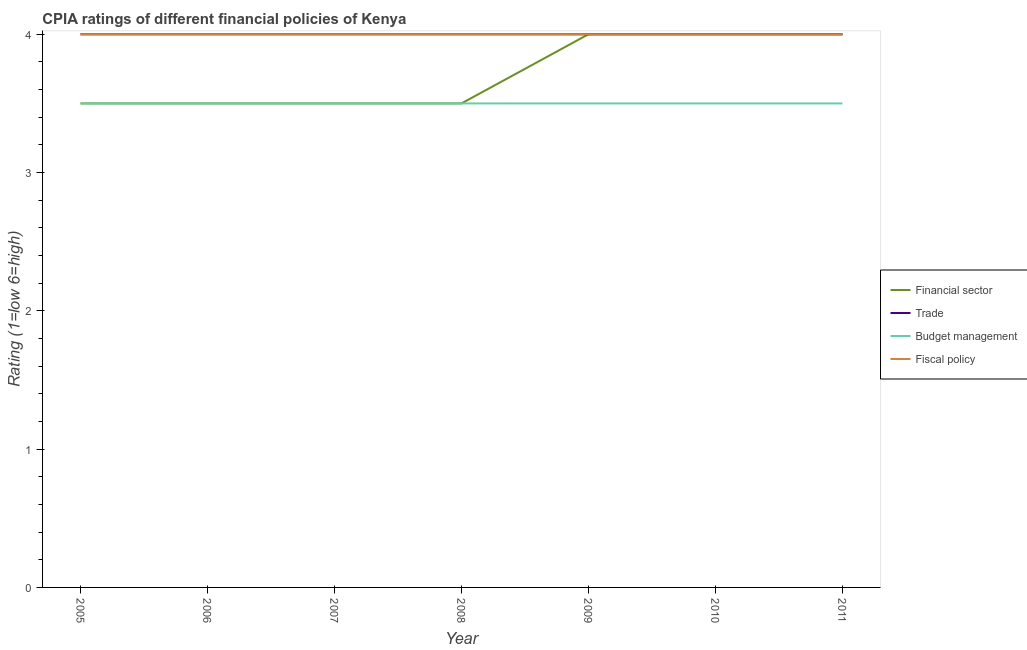Does the line corresponding to cpia rating of budget management intersect with the line corresponding to cpia rating of fiscal policy?
Provide a succinct answer. No. Across all years, what is the maximum cpia rating of budget management?
Your answer should be compact. 3.5. In which year was the cpia rating of fiscal policy minimum?
Keep it short and to the point. 2005. What is the total cpia rating of financial sector in the graph?
Provide a succinct answer. 26. What is the difference between the cpia rating of budget management in 2005 and that in 2008?
Your answer should be very brief. 0. What is the average cpia rating of financial sector per year?
Provide a succinct answer. 3.71. In the year 2011, what is the difference between the cpia rating of financial sector and cpia rating of budget management?
Your answer should be compact. 0.5. What is the ratio of the cpia rating of financial sector in 2008 to that in 2010?
Ensure brevity in your answer.  0.88. Is the cpia rating of fiscal policy in 2008 less than that in 2011?
Offer a very short reply. No. What is the difference between the highest and the second highest cpia rating of budget management?
Provide a short and direct response. 0. Is it the case that in every year, the sum of the cpia rating of fiscal policy and cpia rating of trade is greater than the sum of cpia rating of financial sector and cpia rating of budget management?
Your response must be concise. No. Does the cpia rating of trade monotonically increase over the years?
Offer a very short reply. No. Is the cpia rating of fiscal policy strictly less than the cpia rating of budget management over the years?
Your answer should be very brief. No. What is the difference between two consecutive major ticks on the Y-axis?
Your response must be concise. 1. How are the legend labels stacked?
Keep it short and to the point. Vertical. What is the title of the graph?
Offer a very short reply. CPIA ratings of different financial policies of Kenya. What is the label or title of the X-axis?
Provide a succinct answer. Year. What is the Rating (1=low 6=high) in Fiscal policy in 2005?
Give a very brief answer. 4. What is the Rating (1=low 6=high) of Financial sector in 2006?
Your response must be concise. 3.5. What is the Rating (1=low 6=high) in Budget management in 2006?
Your answer should be very brief. 3.5. What is the Rating (1=low 6=high) in Trade in 2007?
Keep it short and to the point. 4. What is the Rating (1=low 6=high) of Fiscal policy in 2007?
Keep it short and to the point. 4. What is the Rating (1=low 6=high) of Financial sector in 2008?
Give a very brief answer. 3.5. What is the Rating (1=low 6=high) in Trade in 2008?
Ensure brevity in your answer.  4. What is the Rating (1=low 6=high) of Budget management in 2008?
Your response must be concise. 3.5. What is the Rating (1=low 6=high) of Budget management in 2009?
Give a very brief answer. 3.5. What is the Rating (1=low 6=high) of Financial sector in 2010?
Offer a very short reply. 4. What is the Rating (1=low 6=high) in Budget management in 2010?
Offer a terse response. 3.5. What is the Rating (1=low 6=high) in Fiscal policy in 2010?
Offer a very short reply. 4. What is the Rating (1=low 6=high) of Trade in 2011?
Ensure brevity in your answer.  4. Across all years, what is the minimum Rating (1=low 6=high) in Fiscal policy?
Give a very brief answer. 4. What is the total Rating (1=low 6=high) of Budget management in the graph?
Ensure brevity in your answer.  24.5. What is the total Rating (1=low 6=high) in Fiscal policy in the graph?
Provide a succinct answer. 28. What is the difference between the Rating (1=low 6=high) in Financial sector in 2005 and that in 2006?
Provide a succinct answer. 0. What is the difference between the Rating (1=low 6=high) of Trade in 2005 and that in 2006?
Offer a terse response. 0. What is the difference between the Rating (1=low 6=high) in Financial sector in 2005 and that in 2007?
Keep it short and to the point. 0. What is the difference between the Rating (1=low 6=high) of Budget management in 2005 and that in 2007?
Provide a succinct answer. 0. What is the difference between the Rating (1=low 6=high) of Budget management in 2005 and that in 2008?
Make the answer very short. 0. What is the difference between the Rating (1=low 6=high) in Fiscal policy in 2005 and that in 2008?
Ensure brevity in your answer.  0. What is the difference between the Rating (1=low 6=high) of Financial sector in 2005 and that in 2009?
Provide a succinct answer. -0.5. What is the difference between the Rating (1=low 6=high) of Trade in 2005 and that in 2009?
Provide a short and direct response. 0. What is the difference between the Rating (1=low 6=high) in Fiscal policy in 2005 and that in 2009?
Offer a very short reply. 0. What is the difference between the Rating (1=low 6=high) in Financial sector in 2005 and that in 2010?
Your answer should be compact. -0.5. What is the difference between the Rating (1=low 6=high) in Trade in 2005 and that in 2010?
Provide a succinct answer. 0. What is the difference between the Rating (1=low 6=high) of Fiscal policy in 2005 and that in 2010?
Provide a short and direct response. 0. What is the difference between the Rating (1=low 6=high) of Financial sector in 2005 and that in 2011?
Provide a short and direct response. -0.5. What is the difference between the Rating (1=low 6=high) of Financial sector in 2006 and that in 2007?
Your response must be concise. 0. What is the difference between the Rating (1=low 6=high) in Trade in 2006 and that in 2008?
Keep it short and to the point. 0. What is the difference between the Rating (1=low 6=high) in Budget management in 2006 and that in 2008?
Offer a terse response. 0. What is the difference between the Rating (1=low 6=high) of Fiscal policy in 2006 and that in 2008?
Provide a succinct answer. 0. What is the difference between the Rating (1=low 6=high) of Financial sector in 2006 and that in 2009?
Your response must be concise. -0.5. What is the difference between the Rating (1=low 6=high) of Trade in 2006 and that in 2009?
Your answer should be very brief. 0. What is the difference between the Rating (1=low 6=high) of Budget management in 2006 and that in 2009?
Keep it short and to the point. 0. What is the difference between the Rating (1=low 6=high) in Trade in 2006 and that in 2010?
Your answer should be very brief. 0. What is the difference between the Rating (1=low 6=high) in Financial sector in 2006 and that in 2011?
Your answer should be very brief. -0.5. What is the difference between the Rating (1=low 6=high) in Trade in 2006 and that in 2011?
Offer a terse response. 0. What is the difference between the Rating (1=low 6=high) of Budget management in 2006 and that in 2011?
Keep it short and to the point. 0. What is the difference between the Rating (1=low 6=high) of Fiscal policy in 2006 and that in 2011?
Your response must be concise. 0. What is the difference between the Rating (1=low 6=high) of Trade in 2007 and that in 2008?
Your answer should be compact. 0. What is the difference between the Rating (1=low 6=high) of Financial sector in 2007 and that in 2009?
Make the answer very short. -0.5. What is the difference between the Rating (1=low 6=high) of Trade in 2007 and that in 2009?
Your answer should be compact. 0. What is the difference between the Rating (1=low 6=high) of Fiscal policy in 2007 and that in 2009?
Give a very brief answer. 0. What is the difference between the Rating (1=low 6=high) in Trade in 2007 and that in 2010?
Your answer should be very brief. 0. What is the difference between the Rating (1=low 6=high) in Budget management in 2007 and that in 2010?
Make the answer very short. 0. What is the difference between the Rating (1=low 6=high) in Trade in 2007 and that in 2011?
Provide a short and direct response. 0. What is the difference between the Rating (1=low 6=high) in Fiscal policy in 2007 and that in 2011?
Provide a succinct answer. 0. What is the difference between the Rating (1=low 6=high) in Financial sector in 2008 and that in 2009?
Your response must be concise. -0.5. What is the difference between the Rating (1=low 6=high) of Trade in 2008 and that in 2009?
Provide a succinct answer. 0. What is the difference between the Rating (1=low 6=high) of Fiscal policy in 2008 and that in 2009?
Offer a very short reply. 0. What is the difference between the Rating (1=low 6=high) in Financial sector in 2008 and that in 2010?
Provide a short and direct response. -0.5. What is the difference between the Rating (1=low 6=high) in Budget management in 2008 and that in 2010?
Your answer should be compact. 0. What is the difference between the Rating (1=low 6=high) in Fiscal policy in 2008 and that in 2010?
Give a very brief answer. 0. What is the difference between the Rating (1=low 6=high) of Budget management in 2008 and that in 2011?
Offer a terse response. 0. What is the difference between the Rating (1=low 6=high) of Financial sector in 2009 and that in 2010?
Give a very brief answer. 0. What is the difference between the Rating (1=low 6=high) in Trade in 2009 and that in 2010?
Your response must be concise. 0. What is the difference between the Rating (1=low 6=high) in Financial sector in 2009 and that in 2011?
Keep it short and to the point. 0. What is the difference between the Rating (1=low 6=high) in Trade in 2009 and that in 2011?
Provide a short and direct response. 0. What is the difference between the Rating (1=low 6=high) of Fiscal policy in 2010 and that in 2011?
Make the answer very short. 0. What is the difference between the Rating (1=low 6=high) in Financial sector in 2005 and the Rating (1=low 6=high) in Budget management in 2006?
Offer a very short reply. 0. What is the difference between the Rating (1=low 6=high) in Trade in 2005 and the Rating (1=low 6=high) in Budget management in 2006?
Offer a terse response. 0.5. What is the difference between the Rating (1=low 6=high) of Trade in 2005 and the Rating (1=low 6=high) of Fiscal policy in 2006?
Make the answer very short. 0. What is the difference between the Rating (1=low 6=high) of Budget management in 2005 and the Rating (1=low 6=high) of Fiscal policy in 2006?
Offer a terse response. -0.5. What is the difference between the Rating (1=low 6=high) in Financial sector in 2005 and the Rating (1=low 6=high) in Budget management in 2007?
Keep it short and to the point. 0. What is the difference between the Rating (1=low 6=high) in Trade in 2005 and the Rating (1=low 6=high) in Fiscal policy in 2007?
Give a very brief answer. 0. What is the difference between the Rating (1=low 6=high) of Budget management in 2005 and the Rating (1=low 6=high) of Fiscal policy in 2007?
Ensure brevity in your answer.  -0.5. What is the difference between the Rating (1=low 6=high) in Financial sector in 2005 and the Rating (1=low 6=high) in Trade in 2008?
Your response must be concise. -0.5. What is the difference between the Rating (1=low 6=high) in Financial sector in 2005 and the Rating (1=low 6=high) in Budget management in 2008?
Provide a short and direct response. 0. What is the difference between the Rating (1=low 6=high) of Financial sector in 2005 and the Rating (1=low 6=high) of Fiscal policy in 2008?
Ensure brevity in your answer.  -0.5. What is the difference between the Rating (1=low 6=high) of Trade in 2005 and the Rating (1=low 6=high) of Fiscal policy in 2008?
Offer a very short reply. 0. What is the difference between the Rating (1=low 6=high) in Budget management in 2005 and the Rating (1=low 6=high) in Fiscal policy in 2008?
Your response must be concise. -0.5. What is the difference between the Rating (1=low 6=high) of Financial sector in 2005 and the Rating (1=low 6=high) of Fiscal policy in 2009?
Give a very brief answer. -0.5. What is the difference between the Rating (1=low 6=high) in Trade in 2005 and the Rating (1=low 6=high) in Budget management in 2009?
Your answer should be compact. 0.5. What is the difference between the Rating (1=low 6=high) of Financial sector in 2005 and the Rating (1=low 6=high) of Budget management in 2010?
Offer a terse response. 0. What is the difference between the Rating (1=low 6=high) of Financial sector in 2005 and the Rating (1=low 6=high) of Fiscal policy in 2010?
Provide a succinct answer. -0.5. What is the difference between the Rating (1=low 6=high) in Budget management in 2005 and the Rating (1=low 6=high) in Fiscal policy in 2010?
Your response must be concise. -0.5. What is the difference between the Rating (1=low 6=high) of Financial sector in 2005 and the Rating (1=low 6=high) of Trade in 2011?
Provide a short and direct response. -0.5. What is the difference between the Rating (1=low 6=high) of Financial sector in 2005 and the Rating (1=low 6=high) of Budget management in 2011?
Provide a succinct answer. 0. What is the difference between the Rating (1=low 6=high) in Financial sector in 2005 and the Rating (1=low 6=high) in Fiscal policy in 2011?
Your answer should be compact. -0.5. What is the difference between the Rating (1=low 6=high) of Trade in 2005 and the Rating (1=low 6=high) of Budget management in 2011?
Keep it short and to the point. 0.5. What is the difference between the Rating (1=low 6=high) in Financial sector in 2006 and the Rating (1=low 6=high) in Budget management in 2007?
Provide a succinct answer. 0. What is the difference between the Rating (1=low 6=high) of Financial sector in 2006 and the Rating (1=low 6=high) of Fiscal policy in 2007?
Ensure brevity in your answer.  -0.5. What is the difference between the Rating (1=low 6=high) of Budget management in 2006 and the Rating (1=low 6=high) of Fiscal policy in 2007?
Provide a short and direct response. -0.5. What is the difference between the Rating (1=low 6=high) in Financial sector in 2006 and the Rating (1=low 6=high) in Budget management in 2008?
Offer a very short reply. 0. What is the difference between the Rating (1=low 6=high) in Trade in 2006 and the Rating (1=low 6=high) in Budget management in 2008?
Your answer should be compact. 0.5. What is the difference between the Rating (1=low 6=high) of Trade in 2006 and the Rating (1=low 6=high) of Fiscal policy in 2008?
Give a very brief answer. 0. What is the difference between the Rating (1=low 6=high) of Financial sector in 2006 and the Rating (1=low 6=high) of Trade in 2009?
Your response must be concise. -0.5. What is the difference between the Rating (1=low 6=high) of Financial sector in 2006 and the Rating (1=low 6=high) of Budget management in 2009?
Provide a succinct answer. 0. What is the difference between the Rating (1=low 6=high) of Financial sector in 2006 and the Rating (1=low 6=high) of Fiscal policy in 2009?
Provide a short and direct response. -0.5. What is the difference between the Rating (1=low 6=high) of Trade in 2006 and the Rating (1=low 6=high) of Budget management in 2009?
Give a very brief answer. 0.5. What is the difference between the Rating (1=low 6=high) of Budget management in 2006 and the Rating (1=low 6=high) of Fiscal policy in 2009?
Your response must be concise. -0.5. What is the difference between the Rating (1=low 6=high) of Financial sector in 2006 and the Rating (1=low 6=high) of Trade in 2010?
Offer a very short reply. -0.5. What is the difference between the Rating (1=low 6=high) of Budget management in 2006 and the Rating (1=low 6=high) of Fiscal policy in 2010?
Provide a short and direct response. -0.5. What is the difference between the Rating (1=low 6=high) in Financial sector in 2006 and the Rating (1=low 6=high) in Budget management in 2011?
Your answer should be compact. 0. What is the difference between the Rating (1=low 6=high) in Financial sector in 2006 and the Rating (1=low 6=high) in Fiscal policy in 2011?
Offer a terse response. -0.5. What is the difference between the Rating (1=low 6=high) in Trade in 2006 and the Rating (1=low 6=high) in Budget management in 2011?
Provide a short and direct response. 0.5. What is the difference between the Rating (1=low 6=high) in Budget management in 2006 and the Rating (1=low 6=high) in Fiscal policy in 2011?
Offer a terse response. -0.5. What is the difference between the Rating (1=low 6=high) of Financial sector in 2007 and the Rating (1=low 6=high) of Trade in 2008?
Ensure brevity in your answer.  -0.5. What is the difference between the Rating (1=low 6=high) in Trade in 2007 and the Rating (1=low 6=high) in Budget management in 2008?
Your answer should be very brief. 0.5. What is the difference between the Rating (1=low 6=high) of Trade in 2007 and the Rating (1=low 6=high) of Fiscal policy in 2008?
Keep it short and to the point. 0. What is the difference between the Rating (1=low 6=high) of Financial sector in 2007 and the Rating (1=low 6=high) of Budget management in 2009?
Ensure brevity in your answer.  0. What is the difference between the Rating (1=low 6=high) of Budget management in 2007 and the Rating (1=low 6=high) of Fiscal policy in 2009?
Provide a succinct answer. -0.5. What is the difference between the Rating (1=low 6=high) of Financial sector in 2007 and the Rating (1=low 6=high) of Fiscal policy in 2010?
Offer a very short reply. -0.5. What is the difference between the Rating (1=low 6=high) of Trade in 2007 and the Rating (1=low 6=high) of Fiscal policy in 2010?
Make the answer very short. 0. What is the difference between the Rating (1=low 6=high) in Financial sector in 2007 and the Rating (1=low 6=high) in Budget management in 2011?
Provide a succinct answer. 0. What is the difference between the Rating (1=low 6=high) of Financial sector in 2007 and the Rating (1=low 6=high) of Fiscal policy in 2011?
Keep it short and to the point. -0.5. What is the difference between the Rating (1=low 6=high) of Trade in 2007 and the Rating (1=low 6=high) of Budget management in 2011?
Your answer should be very brief. 0.5. What is the difference between the Rating (1=low 6=high) of Trade in 2007 and the Rating (1=low 6=high) of Fiscal policy in 2011?
Offer a very short reply. 0. What is the difference between the Rating (1=low 6=high) in Budget management in 2007 and the Rating (1=low 6=high) in Fiscal policy in 2011?
Your response must be concise. -0.5. What is the difference between the Rating (1=low 6=high) in Financial sector in 2008 and the Rating (1=low 6=high) in Budget management in 2009?
Your response must be concise. 0. What is the difference between the Rating (1=low 6=high) in Financial sector in 2008 and the Rating (1=low 6=high) in Fiscal policy in 2009?
Provide a short and direct response. -0.5. What is the difference between the Rating (1=low 6=high) of Trade in 2008 and the Rating (1=low 6=high) of Budget management in 2009?
Offer a terse response. 0.5. What is the difference between the Rating (1=low 6=high) of Trade in 2008 and the Rating (1=low 6=high) of Fiscal policy in 2009?
Your answer should be compact. 0. What is the difference between the Rating (1=low 6=high) of Budget management in 2008 and the Rating (1=low 6=high) of Fiscal policy in 2009?
Provide a succinct answer. -0.5. What is the difference between the Rating (1=low 6=high) in Financial sector in 2008 and the Rating (1=low 6=high) in Trade in 2010?
Offer a terse response. -0.5. What is the difference between the Rating (1=low 6=high) of Financial sector in 2008 and the Rating (1=low 6=high) of Fiscal policy in 2010?
Your answer should be compact. -0.5. What is the difference between the Rating (1=low 6=high) of Trade in 2008 and the Rating (1=low 6=high) of Budget management in 2010?
Offer a very short reply. 0.5. What is the difference between the Rating (1=low 6=high) in Financial sector in 2008 and the Rating (1=low 6=high) in Trade in 2011?
Offer a terse response. -0.5. What is the difference between the Rating (1=low 6=high) in Financial sector in 2008 and the Rating (1=low 6=high) in Budget management in 2011?
Ensure brevity in your answer.  0. What is the difference between the Rating (1=low 6=high) in Budget management in 2008 and the Rating (1=low 6=high) in Fiscal policy in 2011?
Your answer should be compact. -0.5. What is the difference between the Rating (1=low 6=high) of Trade in 2009 and the Rating (1=low 6=high) of Fiscal policy in 2010?
Your response must be concise. 0. What is the difference between the Rating (1=low 6=high) in Financial sector in 2009 and the Rating (1=low 6=high) in Fiscal policy in 2011?
Make the answer very short. 0. What is the difference between the Rating (1=low 6=high) of Trade in 2009 and the Rating (1=low 6=high) of Fiscal policy in 2011?
Make the answer very short. 0. What is the difference between the Rating (1=low 6=high) in Budget management in 2009 and the Rating (1=low 6=high) in Fiscal policy in 2011?
Offer a very short reply. -0.5. What is the difference between the Rating (1=low 6=high) in Financial sector in 2010 and the Rating (1=low 6=high) in Trade in 2011?
Ensure brevity in your answer.  0. What is the difference between the Rating (1=low 6=high) of Financial sector in 2010 and the Rating (1=low 6=high) of Budget management in 2011?
Your answer should be very brief. 0.5. What is the difference between the Rating (1=low 6=high) of Trade in 2010 and the Rating (1=low 6=high) of Fiscal policy in 2011?
Offer a very short reply. 0. What is the average Rating (1=low 6=high) in Financial sector per year?
Your answer should be very brief. 3.71. What is the average Rating (1=low 6=high) of Budget management per year?
Ensure brevity in your answer.  3.5. What is the average Rating (1=low 6=high) in Fiscal policy per year?
Provide a succinct answer. 4. In the year 2005, what is the difference between the Rating (1=low 6=high) in Financial sector and Rating (1=low 6=high) in Fiscal policy?
Your answer should be compact. -0.5. In the year 2006, what is the difference between the Rating (1=low 6=high) in Financial sector and Rating (1=low 6=high) in Trade?
Offer a very short reply. -0.5. In the year 2006, what is the difference between the Rating (1=low 6=high) of Financial sector and Rating (1=low 6=high) of Budget management?
Give a very brief answer. 0. In the year 2006, what is the difference between the Rating (1=low 6=high) in Financial sector and Rating (1=low 6=high) in Fiscal policy?
Offer a terse response. -0.5. In the year 2006, what is the difference between the Rating (1=low 6=high) in Trade and Rating (1=low 6=high) in Budget management?
Your answer should be compact. 0.5. In the year 2006, what is the difference between the Rating (1=low 6=high) in Trade and Rating (1=low 6=high) in Fiscal policy?
Keep it short and to the point. 0. In the year 2006, what is the difference between the Rating (1=low 6=high) in Budget management and Rating (1=low 6=high) in Fiscal policy?
Provide a short and direct response. -0.5. In the year 2007, what is the difference between the Rating (1=low 6=high) of Financial sector and Rating (1=low 6=high) of Fiscal policy?
Keep it short and to the point. -0.5. In the year 2007, what is the difference between the Rating (1=low 6=high) of Trade and Rating (1=low 6=high) of Fiscal policy?
Provide a succinct answer. 0. In the year 2007, what is the difference between the Rating (1=low 6=high) in Budget management and Rating (1=low 6=high) in Fiscal policy?
Provide a short and direct response. -0.5. In the year 2008, what is the difference between the Rating (1=low 6=high) of Financial sector and Rating (1=low 6=high) of Trade?
Make the answer very short. -0.5. In the year 2008, what is the difference between the Rating (1=low 6=high) in Financial sector and Rating (1=low 6=high) in Fiscal policy?
Make the answer very short. -0.5. In the year 2008, what is the difference between the Rating (1=low 6=high) of Trade and Rating (1=low 6=high) of Budget management?
Your response must be concise. 0.5. In the year 2009, what is the difference between the Rating (1=low 6=high) in Financial sector and Rating (1=low 6=high) in Fiscal policy?
Your answer should be very brief. 0. In the year 2009, what is the difference between the Rating (1=low 6=high) in Trade and Rating (1=low 6=high) in Budget management?
Give a very brief answer. 0.5. In the year 2010, what is the difference between the Rating (1=low 6=high) in Financial sector and Rating (1=low 6=high) in Budget management?
Your answer should be very brief. 0.5. In the year 2010, what is the difference between the Rating (1=low 6=high) of Trade and Rating (1=low 6=high) of Budget management?
Give a very brief answer. 0.5. In the year 2010, what is the difference between the Rating (1=low 6=high) of Trade and Rating (1=low 6=high) of Fiscal policy?
Ensure brevity in your answer.  0. In the year 2011, what is the difference between the Rating (1=low 6=high) of Financial sector and Rating (1=low 6=high) of Trade?
Your answer should be very brief. 0. In the year 2011, what is the difference between the Rating (1=low 6=high) in Financial sector and Rating (1=low 6=high) in Fiscal policy?
Provide a succinct answer. 0. In the year 2011, what is the difference between the Rating (1=low 6=high) of Trade and Rating (1=low 6=high) of Fiscal policy?
Your answer should be compact. 0. In the year 2011, what is the difference between the Rating (1=low 6=high) in Budget management and Rating (1=low 6=high) in Fiscal policy?
Your answer should be compact. -0.5. What is the ratio of the Rating (1=low 6=high) in Financial sector in 2005 to that in 2006?
Provide a succinct answer. 1. What is the ratio of the Rating (1=low 6=high) in Budget management in 2005 to that in 2006?
Your response must be concise. 1. What is the ratio of the Rating (1=low 6=high) of Fiscal policy in 2005 to that in 2006?
Ensure brevity in your answer.  1. What is the ratio of the Rating (1=low 6=high) of Financial sector in 2005 to that in 2007?
Your answer should be very brief. 1. What is the ratio of the Rating (1=low 6=high) of Trade in 2005 to that in 2007?
Offer a terse response. 1. What is the ratio of the Rating (1=low 6=high) in Budget management in 2005 to that in 2007?
Make the answer very short. 1. What is the ratio of the Rating (1=low 6=high) in Fiscal policy in 2005 to that in 2007?
Your answer should be compact. 1. What is the ratio of the Rating (1=low 6=high) in Budget management in 2005 to that in 2008?
Your answer should be compact. 1. What is the ratio of the Rating (1=low 6=high) of Fiscal policy in 2005 to that in 2008?
Provide a short and direct response. 1. What is the ratio of the Rating (1=low 6=high) in Budget management in 2005 to that in 2009?
Your response must be concise. 1. What is the ratio of the Rating (1=low 6=high) in Fiscal policy in 2005 to that in 2009?
Offer a terse response. 1. What is the ratio of the Rating (1=low 6=high) of Trade in 2005 to that in 2011?
Keep it short and to the point. 1. What is the ratio of the Rating (1=low 6=high) of Budget management in 2005 to that in 2011?
Offer a very short reply. 1. What is the ratio of the Rating (1=low 6=high) in Financial sector in 2006 to that in 2007?
Your answer should be compact. 1. What is the ratio of the Rating (1=low 6=high) of Budget management in 2006 to that in 2007?
Provide a short and direct response. 1. What is the ratio of the Rating (1=low 6=high) in Fiscal policy in 2006 to that in 2007?
Provide a succinct answer. 1. What is the ratio of the Rating (1=low 6=high) of Budget management in 2006 to that in 2008?
Keep it short and to the point. 1. What is the ratio of the Rating (1=low 6=high) in Fiscal policy in 2006 to that in 2009?
Offer a very short reply. 1. What is the ratio of the Rating (1=low 6=high) in Financial sector in 2006 to that in 2010?
Provide a succinct answer. 0.88. What is the ratio of the Rating (1=low 6=high) in Trade in 2006 to that in 2010?
Your answer should be compact. 1. What is the ratio of the Rating (1=low 6=high) in Budget management in 2006 to that in 2010?
Provide a succinct answer. 1. What is the ratio of the Rating (1=low 6=high) in Fiscal policy in 2006 to that in 2010?
Your answer should be compact. 1. What is the ratio of the Rating (1=low 6=high) in Financial sector in 2006 to that in 2011?
Your answer should be compact. 0.88. What is the ratio of the Rating (1=low 6=high) in Fiscal policy in 2006 to that in 2011?
Provide a short and direct response. 1. What is the ratio of the Rating (1=low 6=high) in Financial sector in 2007 to that in 2008?
Give a very brief answer. 1. What is the ratio of the Rating (1=low 6=high) in Trade in 2007 to that in 2008?
Offer a terse response. 1. What is the ratio of the Rating (1=low 6=high) of Budget management in 2007 to that in 2008?
Provide a short and direct response. 1. What is the ratio of the Rating (1=low 6=high) in Fiscal policy in 2007 to that in 2008?
Make the answer very short. 1. What is the ratio of the Rating (1=low 6=high) of Financial sector in 2007 to that in 2010?
Provide a short and direct response. 0.88. What is the ratio of the Rating (1=low 6=high) of Trade in 2007 to that in 2010?
Give a very brief answer. 1. What is the ratio of the Rating (1=low 6=high) in Fiscal policy in 2007 to that in 2010?
Your answer should be very brief. 1. What is the ratio of the Rating (1=low 6=high) of Financial sector in 2007 to that in 2011?
Ensure brevity in your answer.  0.88. What is the ratio of the Rating (1=low 6=high) of Trade in 2007 to that in 2011?
Your answer should be compact. 1. What is the ratio of the Rating (1=low 6=high) of Budget management in 2007 to that in 2011?
Provide a short and direct response. 1. What is the ratio of the Rating (1=low 6=high) of Fiscal policy in 2007 to that in 2011?
Provide a succinct answer. 1. What is the ratio of the Rating (1=low 6=high) of Financial sector in 2008 to that in 2011?
Offer a very short reply. 0.88. What is the ratio of the Rating (1=low 6=high) in Trade in 2008 to that in 2011?
Provide a succinct answer. 1. What is the ratio of the Rating (1=low 6=high) in Financial sector in 2009 to that in 2010?
Provide a succinct answer. 1. What is the ratio of the Rating (1=low 6=high) of Trade in 2009 to that in 2010?
Provide a succinct answer. 1. What is the ratio of the Rating (1=low 6=high) of Trade in 2009 to that in 2011?
Make the answer very short. 1. What is the ratio of the Rating (1=low 6=high) of Budget management in 2009 to that in 2011?
Keep it short and to the point. 1. What is the ratio of the Rating (1=low 6=high) in Fiscal policy in 2009 to that in 2011?
Your response must be concise. 1. What is the ratio of the Rating (1=low 6=high) of Financial sector in 2010 to that in 2011?
Your answer should be compact. 1. What is the ratio of the Rating (1=low 6=high) of Budget management in 2010 to that in 2011?
Make the answer very short. 1. What is the ratio of the Rating (1=low 6=high) of Fiscal policy in 2010 to that in 2011?
Make the answer very short. 1. What is the difference between the highest and the second highest Rating (1=low 6=high) in Financial sector?
Make the answer very short. 0. What is the difference between the highest and the second highest Rating (1=low 6=high) in Trade?
Your answer should be compact. 0. What is the difference between the highest and the second highest Rating (1=low 6=high) of Budget management?
Offer a very short reply. 0. What is the difference between the highest and the second highest Rating (1=low 6=high) in Fiscal policy?
Make the answer very short. 0. What is the difference between the highest and the lowest Rating (1=low 6=high) of Financial sector?
Give a very brief answer. 0.5. What is the difference between the highest and the lowest Rating (1=low 6=high) of Trade?
Keep it short and to the point. 0. What is the difference between the highest and the lowest Rating (1=low 6=high) in Budget management?
Provide a short and direct response. 0. 